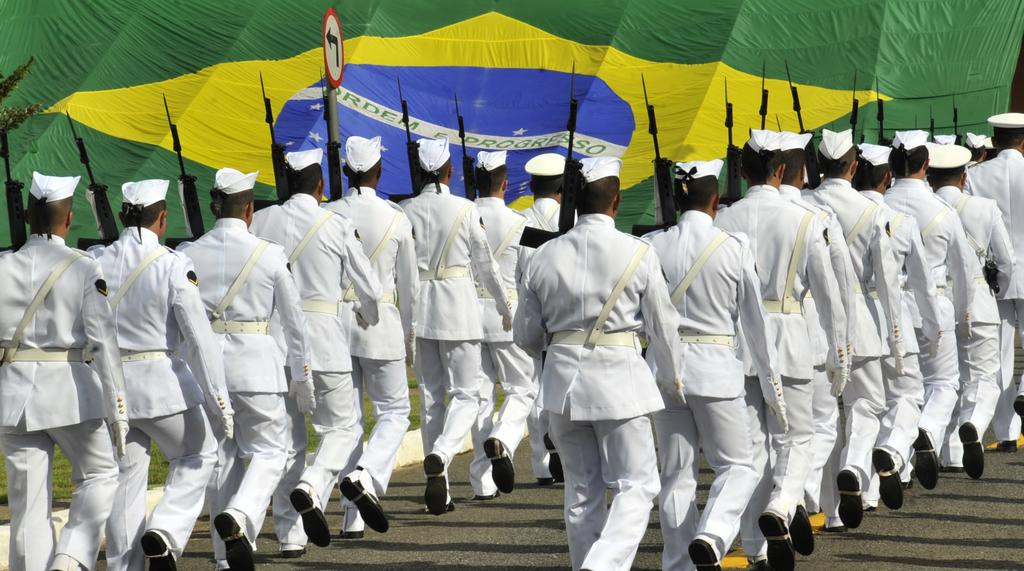Who or what can be seen in the image? There are people in the image. What are the people wearing? The people are wearing white color dresses. What are the people holding in their hands? The people are holding guns. Where are the people walking? The people are walking on a land. What else can be seen in the image besides the people? There is a flag and a tree visible in the image. What is the development process of the journey depicted in the image? There is no journey depicted in the image, as it features people walking on a land while holding guns and wearing white color dresses. 